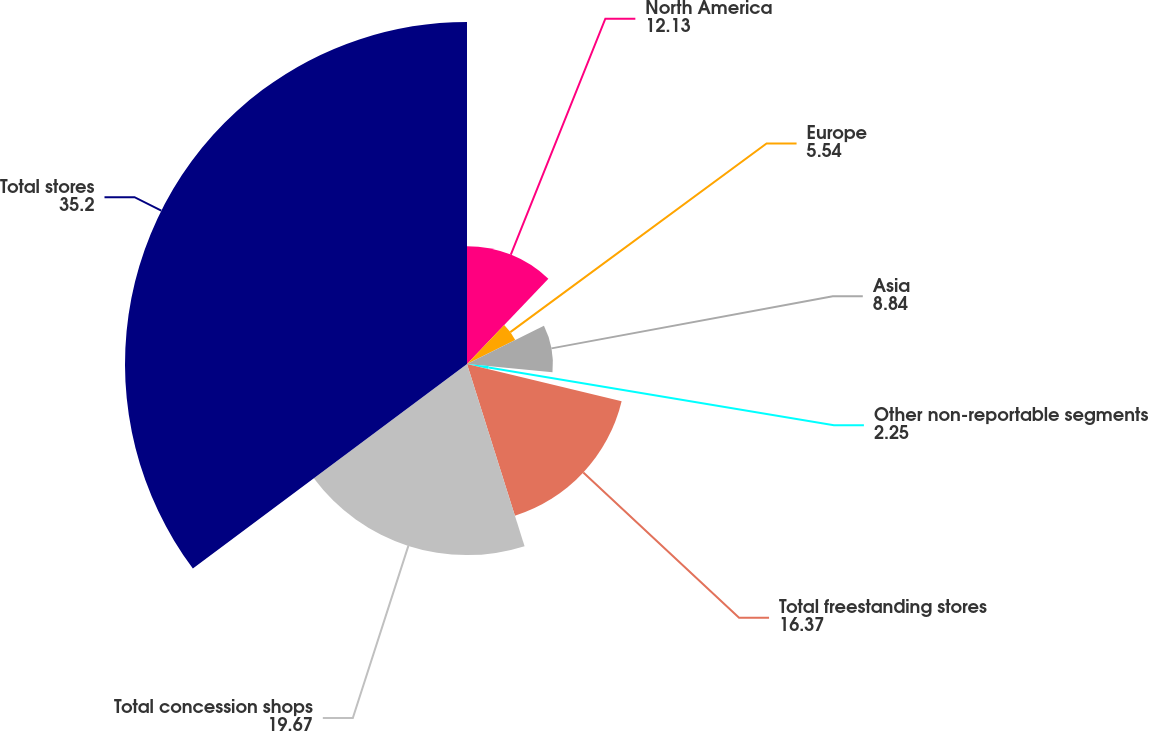<chart> <loc_0><loc_0><loc_500><loc_500><pie_chart><fcel>North America<fcel>Europe<fcel>Asia<fcel>Other non-reportable segments<fcel>Total freestanding stores<fcel>Total concession shops<fcel>Total stores<nl><fcel>12.13%<fcel>5.54%<fcel>8.84%<fcel>2.25%<fcel>16.37%<fcel>19.67%<fcel>35.2%<nl></chart> 